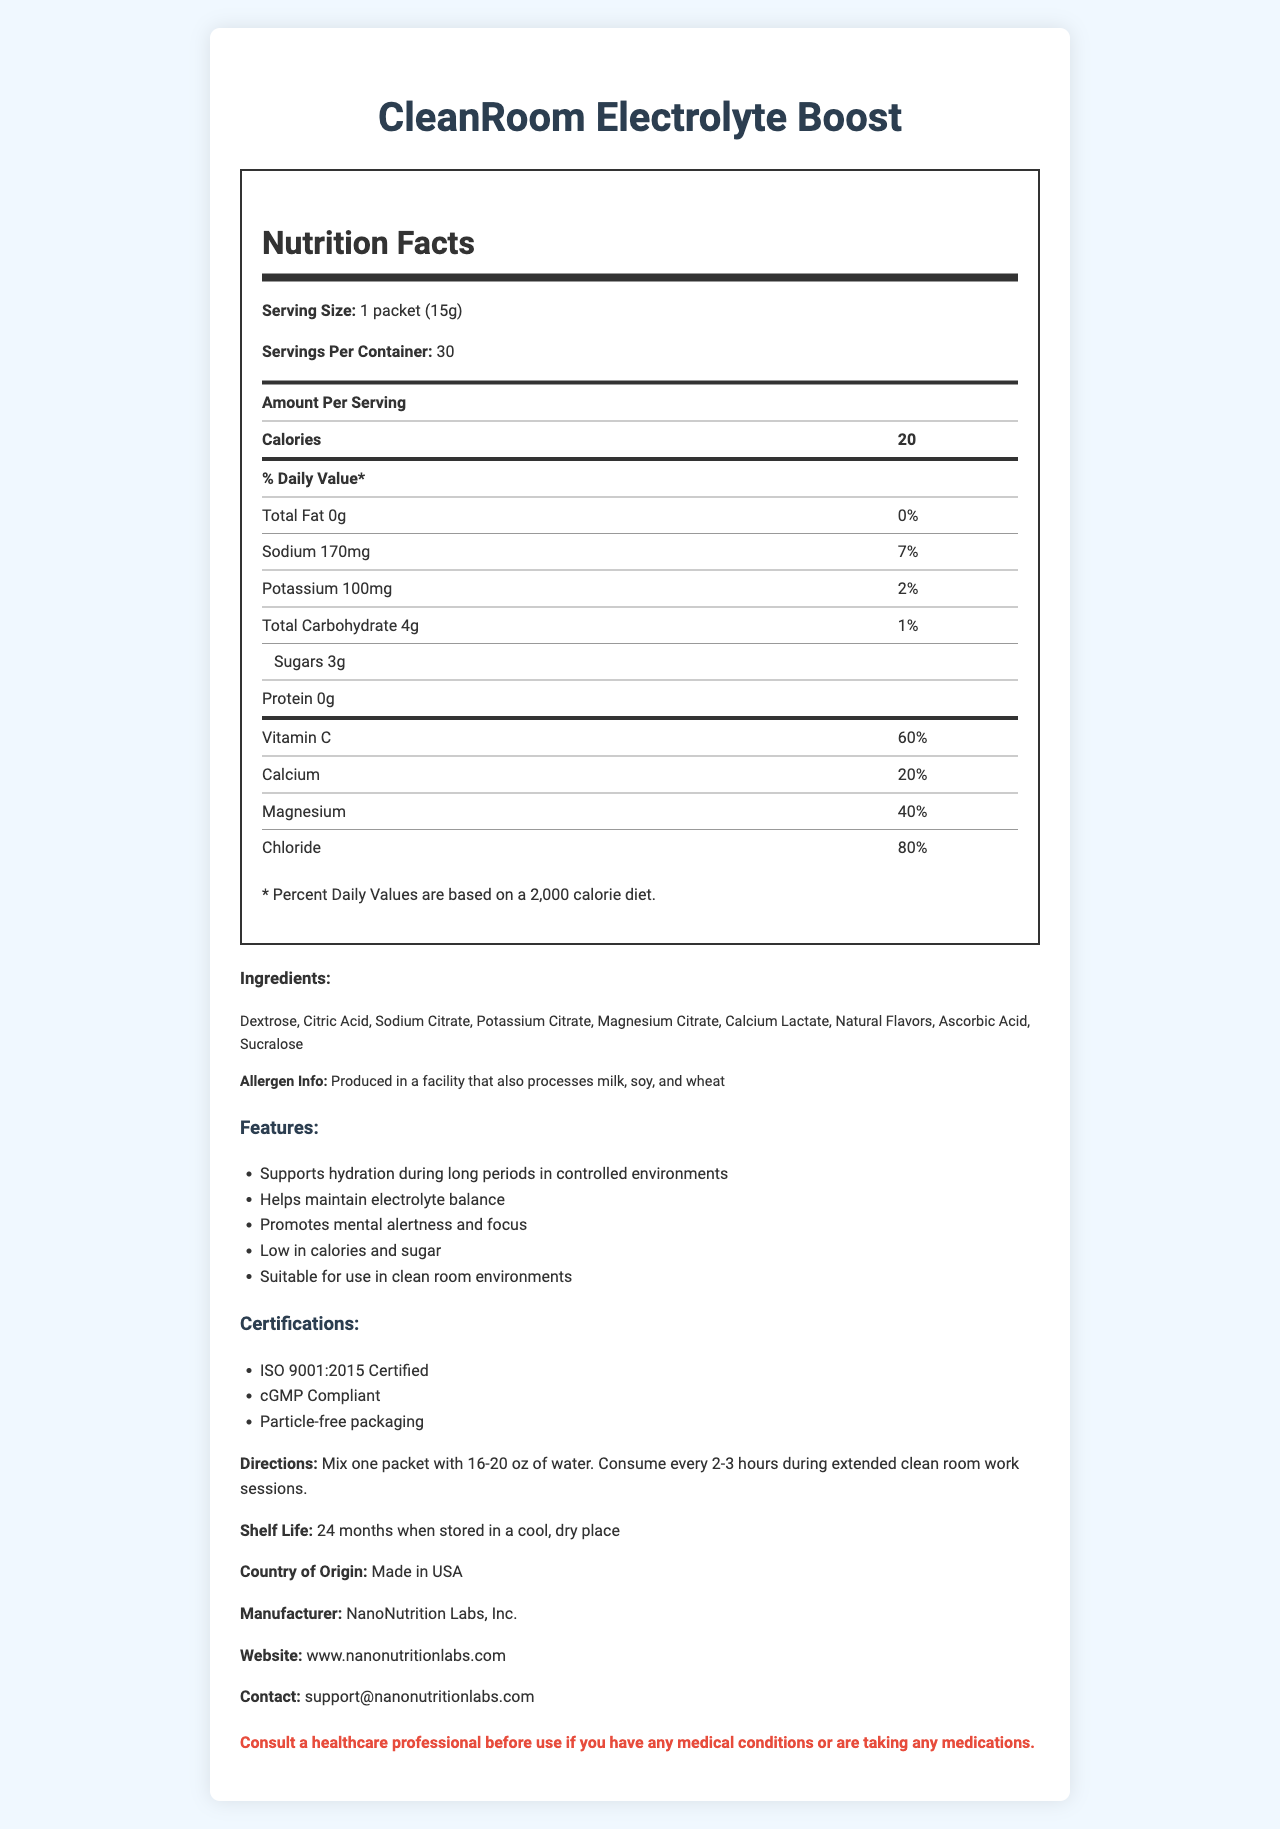What is the serving size of CleanRoom Electrolyte Boost? The document states that the serving size is 1 packet (15g).
Answer: 1 packet (15g) How many servings are there per container? The document indicates that there are 30 servings per container.
Answer: 30 How many calories are there per serving? The document specifies that there are 20 calories per serving.
Answer: 20 What are the main ingredients in CleanRoom Electrolyte Boost? The ingredients list provided in the document states these as the main components.
Answer: Dextrose, Citric Acid, Sodium Citrate, Potassium Citrate, Magnesium Citrate, Calcium Lactate, Natural Flavors, Ascorbic Acid, Sucralose How often should this supplement be consumed during extended work sessions? The directions in the document recommend consuming the product every 2-3 hours during extended clean room work sessions.
Answer: Every 2-3 hours Which of the following is not an ingredient in CleanRoom Electrolyte Boost?
A. Dextrose
B. Sodium Chloride
C. Sucralose The list of ingredients in the document does not include Sodium Chloride, while Dextrose and Sucralose are listed.
Answer: B. Sodium Chloride What percentage of the daily recommended intake of Vitamin C does one serving provide? The document states that one serving provides 60% of the daily recommended intake of Vitamin C.
Answer: 60% Where should the product be stored for maximum shelf life? 
A. In a cool, dry place
B. In the refrigerator
C. In direct sunlight The document specifies that the product should be stored in a cool, dry place.
Answer: A. In a cool, dry place Is CleanRoom Electrolyte Boost certified to be particle-free? The document lists "Particle-free packaging" under certifications.
Answer: Yes What are the possible allergens associated with CleanRoom Electrolyte Boost? The allergen info section in the document mentions that the product is produced in a facility that also processes milk, soy, and wheat.
Answer: Milk, soy, wheat Please summarize the main features of CleanRoom Electrolyte Boost. The document's features section lists these points as the main benefits and characteristics of the product.
Answer: Supports hydration during long periods in controlled environments, helps maintain electrolyte balance, promotes mental alertness and focus, low in calories and sugar, suitable for use in clean room environments What is the primary function of this supplement as per the document? The main idea of the document is that CleanRoom Electrolyte Boost is designed to support hydration, maintain electrolyte balance, and promote mental alertness during long work sessions in controlled environments.
Answer: To support hydration and maintain alertness during extended periods of clean room work What company manufactures CleanRoom Electrolyte Boost? The manufacturer mentioned in the document is NanoNutrition Labs, Inc.
Answer: NanoNutrition Labs, Inc. What is the country of origin for CleanRoom Electrolyte Boost? The document states that the product is made in the USA.
Answer: USA Can the percentage of protein content be determined from the document? There is no percentage provided for the protein content in the document; only the amount is given (0g).
Answer: No What is the product's shelf life? According to the document, the shelf life is 24 months when stored in a cool, dry place.
Answer: 24 months 